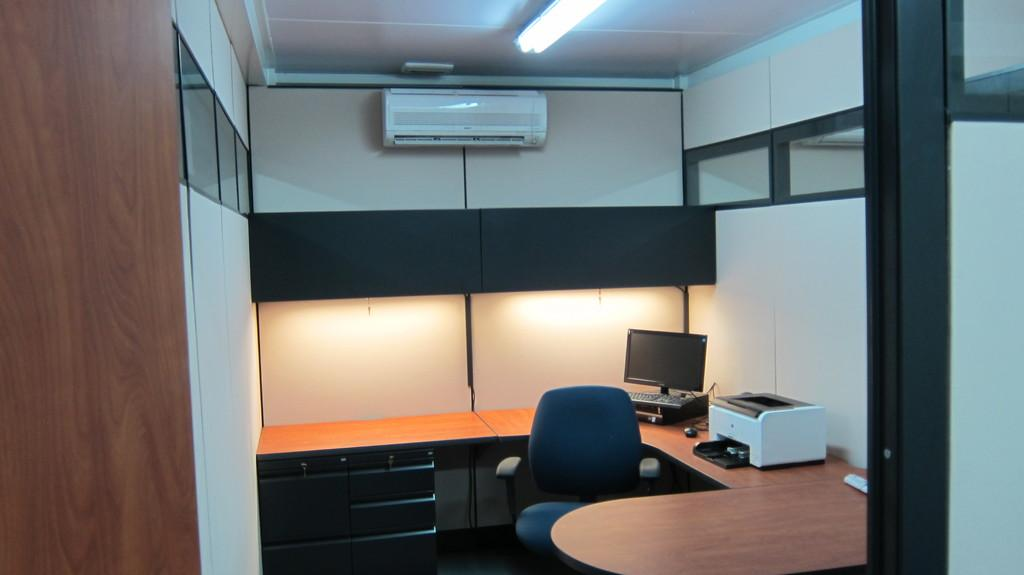Where was the image taken? The image was taken in a room. What can be seen on the ceiling of the room? There is a light and an AC on the top of the room. What type of furniture is present in the room? There are tables and a chair in the room. What electronic devices are on the tables? There is a computer and a printer on one of the tables. What type of protest is happening in the room? There is no protest happening in the room; the image shows a room with furniture and electronic devices. What type of blade is being used to control the temperature in the room? There is no blade present in the image, and the AC is used to control the temperature in the room. 